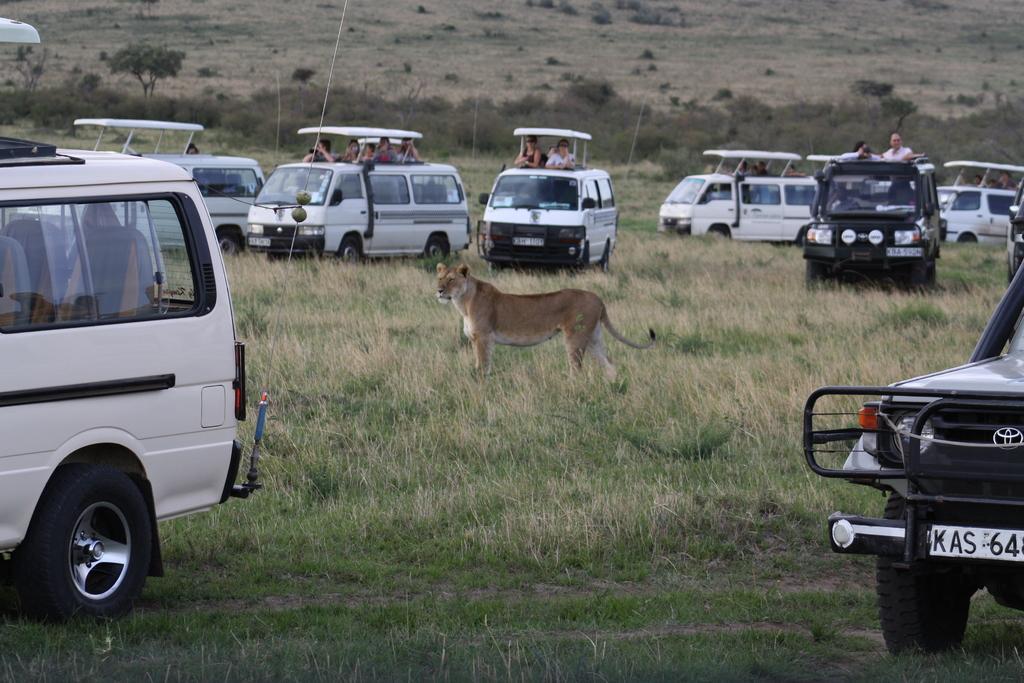How would you summarize this image in a sentence or two? In this image I can see an open grass ground and on it I can see number of vehicles and in the centre I can see a lion is standing. In the background I can see few people on these vehicles. 